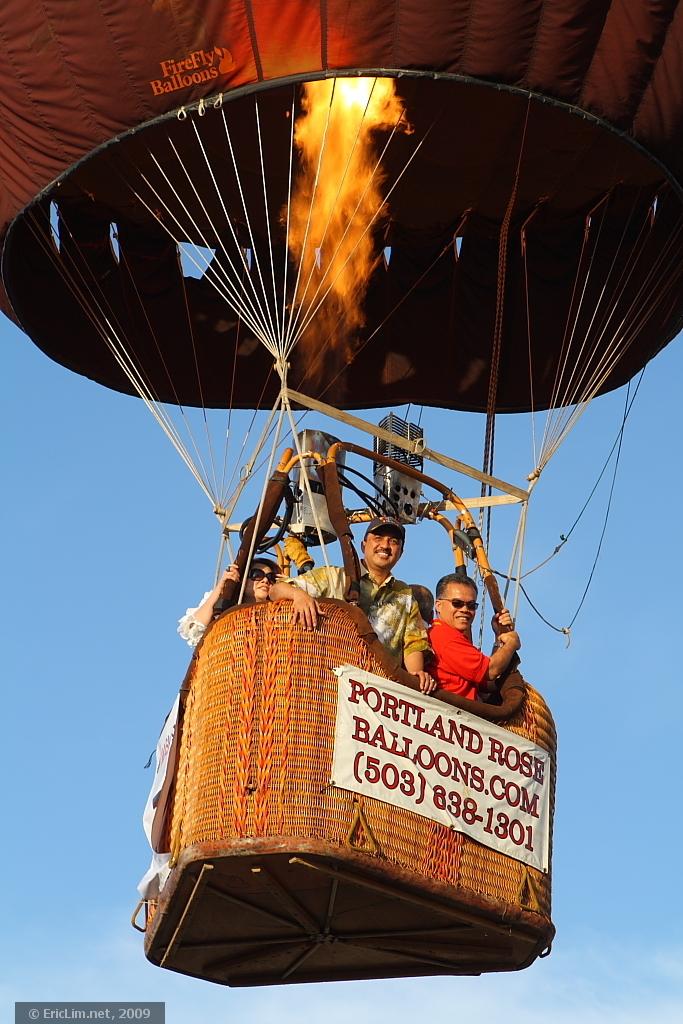What is the phone number on this balloon?
Ensure brevity in your answer.  5038361301. 